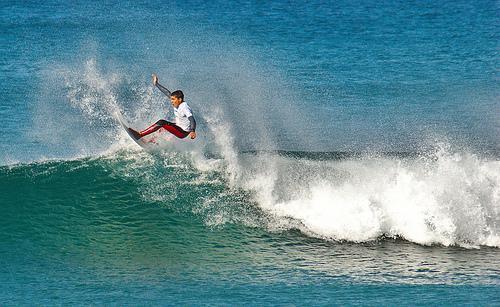How many people are surfing?
Give a very brief answer. 1. 